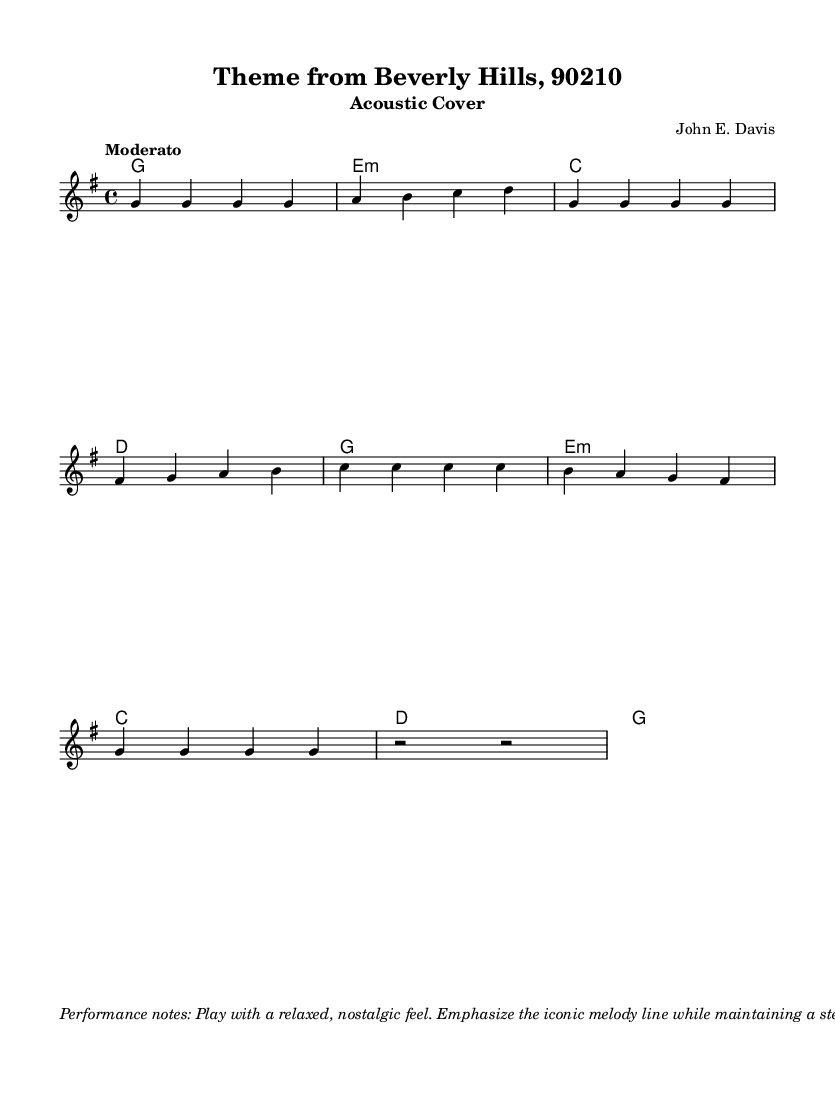What is the key signature of this music? The key signature indicates the tonality, and in this case, there is one sharp (F#), which is characteristic of the key of G major.
Answer: G major What is the time signature of this music? The time signature indicates how many beats are in each measure. Here, it shows 4/4, meaning there are four beats per measure.
Answer: 4/4 What is the tempo marking for this piece? The tempo marking indicates how fast the music should be played. It states "Moderato," which suggests a moderate tempo.
Answer: Moderato Which chord is played in the first measure? The first measure contains a whole note for the G chord, indicating that it is held for the entire measure.
Answer: G How many measures are in the melody section provided? By counting the individual measures in the melody line, we find there are eight measures in total.
Answer: 8 What dynamics are indicated for this performance? The dynamics indicated in the performance notes suggest playing with a level of sound that is moderately loud throughout the piece, which is referred to as mezzoforte.
Answer: mf What type of strumming pattern is suggested for this acoustic cover? The performance notes describe a steady eighth note strumming pattern, which provides a rhythmic foundation for the piece.
Answer: Eighth note 